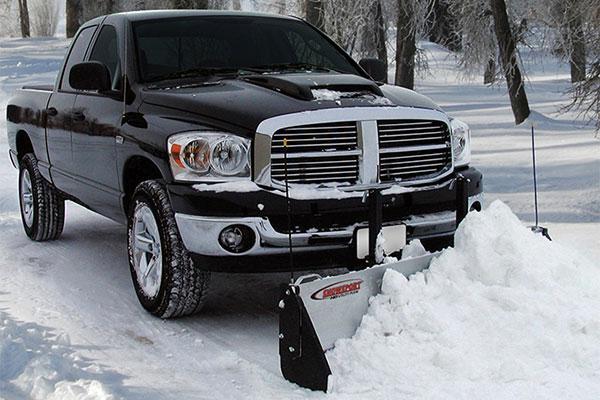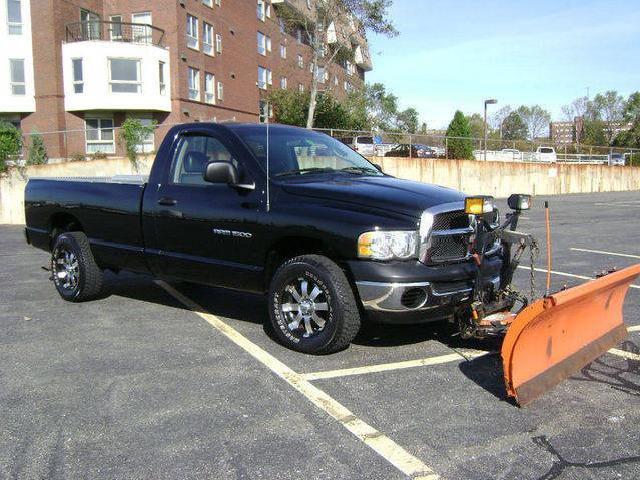The first image is the image on the left, the second image is the image on the right. For the images shown, is this caption "The left and right image contains the same number of black trucks with a plow." true? Answer yes or no. Yes. The first image is the image on the left, the second image is the image on the right. Analyze the images presented: Is the assertion "One image features a rightward-facing truck with a plow on its front, parked on dry pavement with no snow in sight." valid? Answer yes or no. Yes. 